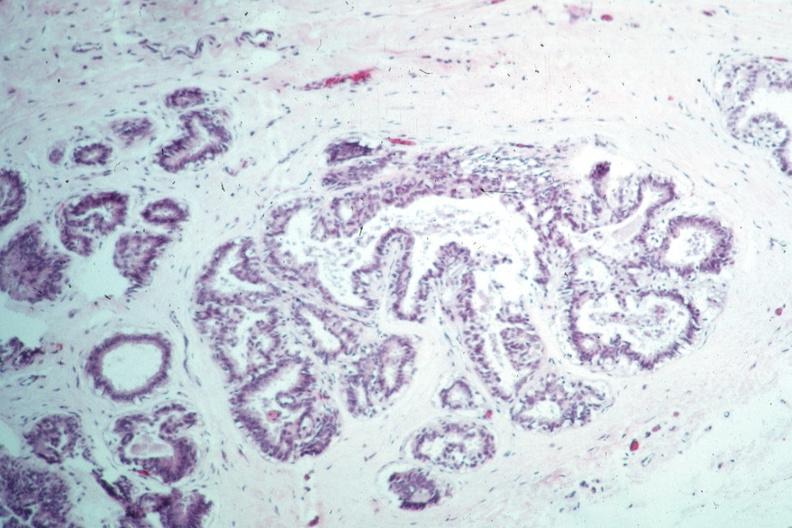s intraductal papillomatosis with apocrine metaplasia present?
Answer the question using a single word or phrase. Yes 